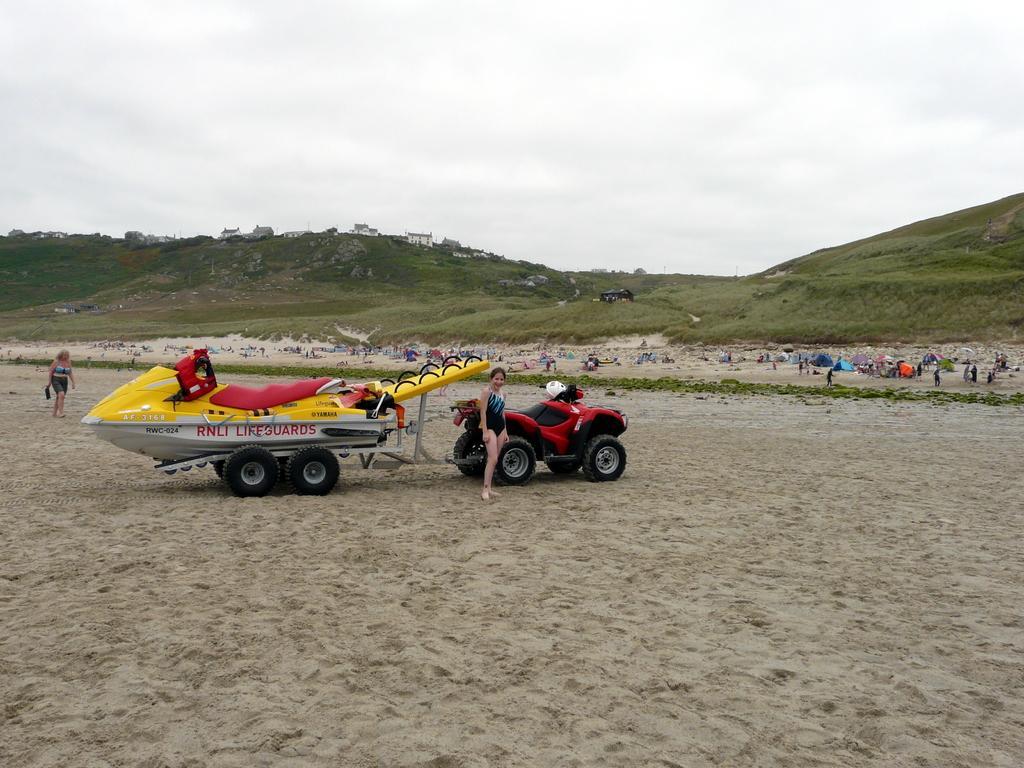Describe this image in one or two sentences. The picture might be taken in a beach. In the foreground of the picture there are vehicles, sand and a person. On the left we can see a woman walking. In the middle of the picture there are people, sand and various objects. In the background we can see grassland, trees and buildings. At the top it is sky, sky is cloudy. 